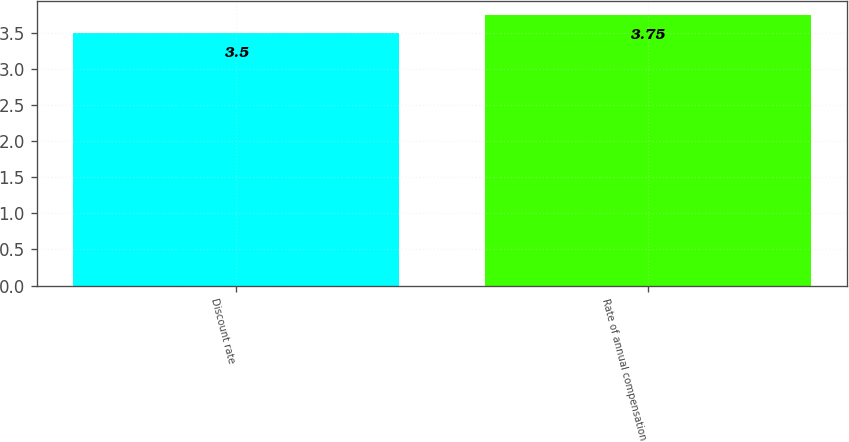Convert chart to OTSL. <chart><loc_0><loc_0><loc_500><loc_500><bar_chart><fcel>Discount rate<fcel>Rate of annual compensation<nl><fcel>3.5<fcel>3.75<nl></chart> 